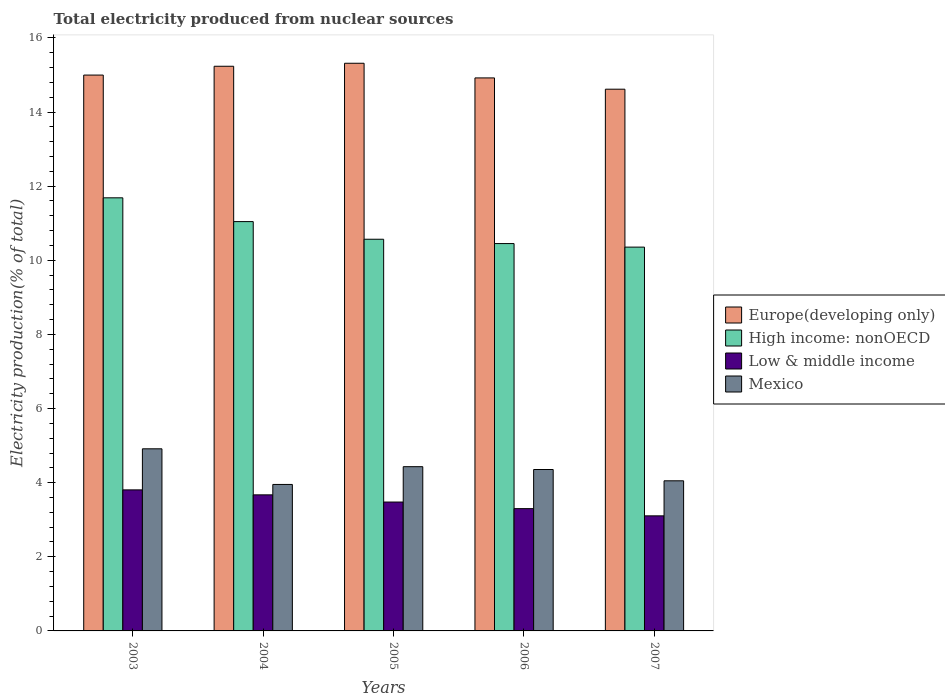How many groups of bars are there?
Offer a very short reply. 5. Are the number of bars on each tick of the X-axis equal?
Your answer should be compact. Yes. How many bars are there on the 4th tick from the left?
Offer a very short reply. 4. How many bars are there on the 4th tick from the right?
Make the answer very short. 4. In how many cases, is the number of bars for a given year not equal to the number of legend labels?
Keep it short and to the point. 0. What is the total electricity produced in Mexico in 2004?
Ensure brevity in your answer.  3.95. Across all years, what is the maximum total electricity produced in Mexico?
Your answer should be compact. 4.91. Across all years, what is the minimum total electricity produced in High income: nonOECD?
Provide a short and direct response. 10.36. What is the total total electricity produced in Europe(developing only) in the graph?
Provide a succinct answer. 75.09. What is the difference between the total electricity produced in Europe(developing only) in 2003 and that in 2004?
Keep it short and to the point. -0.24. What is the difference between the total electricity produced in Low & middle income in 2007 and the total electricity produced in High income: nonOECD in 2005?
Your response must be concise. -7.46. What is the average total electricity produced in High income: nonOECD per year?
Give a very brief answer. 10.82. In the year 2005, what is the difference between the total electricity produced in Low & middle income and total electricity produced in Mexico?
Your answer should be very brief. -0.95. What is the ratio of the total electricity produced in Europe(developing only) in 2004 to that in 2007?
Your answer should be very brief. 1.04. Is the total electricity produced in Europe(developing only) in 2003 less than that in 2005?
Give a very brief answer. Yes. What is the difference between the highest and the second highest total electricity produced in High income: nonOECD?
Provide a succinct answer. 0.64. What is the difference between the highest and the lowest total electricity produced in High income: nonOECD?
Your answer should be very brief. 1.33. What does the 3rd bar from the right in 2006 represents?
Ensure brevity in your answer.  High income: nonOECD. Is it the case that in every year, the sum of the total electricity produced in High income: nonOECD and total electricity produced in Mexico is greater than the total electricity produced in Europe(developing only)?
Keep it short and to the point. No. How many bars are there?
Provide a short and direct response. 20. Are all the bars in the graph horizontal?
Provide a short and direct response. No. Are the values on the major ticks of Y-axis written in scientific E-notation?
Provide a short and direct response. No. Does the graph contain any zero values?
Offer a very short reply. No. Does the graph contain grids?
Offer a very short reply. No. How many legend labels are there?
Your answer should be very brief. 4. What is the title of the graph?
Make the answer very short. Total electricity produced from nuclear sources. Does "Korea (Republic)" appear as one of the legend labels in the graph?
Make the answer very short. No. What is the label or title of the X-axis?
Provide a succinct answer. Years. What is the label or title of the Y-axis?
Make the answer very short. Electricity production(% of total). What is the Electricity production(% of total) of Europe(developing only) in 2003?
Give a very brief answer. 15. What is the Electricity production(% of total) of High income: nonOECD in 2003?
Provide a succinct answer. 11.69. What is the Electricity production(% of total) of Low & middle income in 2003?
Your response must be concise. 3.81. What is the Electricity production(% of total) of Mexico in 2003?
Make the answer very short. 4.91. What is the Electricity production(% of total) in Europe(developing only) in 2004?
Your response must be concise. 15.24. What is the Electricity production(% of total) of High income: nonOECD in 2004?
Your response must be concise. 11.04. What is the Electricity production(% of total) in Low & middle income in 2004?
Make the answer very short. 3.67. What is the Electricity production(% of total) of Mexico in 2004?
Your answer should be very brief. 3.95. What is the Electricity production(% of total) in Europe(developing only) in 2005?
Provide a short and direct response. 15.32. What is the Electricity production(% of total) in High income: nonOECD in 2005?
Provide a short and direct response. 10.57. What is the Electricity production(% of total) of Low & middle income in 2005?
Your response must be concise. 3.48. What is the Electricity production(% of total) in Mexico in 2005?
Provide a short and direct response. 4.43. What is the Electricity production(% of total) in Europe(developing only) in 2006?
Provide a succinct answer. 14.92. What is the Electricity production(% of total) of High income: nonOECD in 2006?
Your answer should be very brief. 10.45. What is the Electricity production(% of total) of Low & middle income in 2006?
Keep it short and to the point. 3.3. What is the Electricity production(% of total) in Mexico in 2006?
Your response must be concise. 4.36. What is the Electricity production(% of total) of Europe(developing only) in 2007?
Your answer should be very brief. 14.62. What is the Electricity production(% of total) in High income: nonOECD in 2007?
Provide a short and direct response. 10.36. What is the Electricity production(% of total) of Low & middle income in 2007?
Ensure brevity in your answer.  3.1. What is the Electricity production(% of total) in Mexico in 2007?
Offer a terse response. 4.05. Across all years, what is the maximum Electricity production(% of total) in Europe(developing only)?
Your answer should be very brief. 15.32. Across all years, what is the maximum Electricity production(% of total) of High income: nonOECD?
Give a very brief answer. 11.69. Across all years, what is the maximum Electricity production(% of total) in Low & middle income?
Your answer should be very brief. 3.81. Across all years, what is the maximum Electricity production(% of total) in Mexico?
Your answer should be compact. 4.91. Across all years, what is the minimum Electricity production(% of total) of Europe(developing only)?
Provide a succinct answer. 14.62. Across all years, what is the minimum Electricity production(% of total) of High income: nonOECD?
Provide a short and direct response. 10.36. Across all years, what is the minimum Electricity production(% of total) in Low & middle income?
Give a very brief answer. 3.1. Across all years, what is the minimum Electricity production(% of total) of Mexico?
Provide a succinct answer. 3.95. What is the total Electricity production(% of total) of Europe(developing only) in the graph?
Make the answer very short. 75.09. What is the total Electricity production(% of total) of High income: nonOECD in the graph?
Offer a very short reply. 54.1. What is the total Electricity production(% of total) in Low & middle income in the graph?
Offer a terse response. 17.36. What is the total Electricity production(% of total) of Mexico in the graph?
Give a very brief answer. 21.7. What is the difference between the Electricity production(% of total) of Europe(developing only) in 2003 and that in 2004?
Your answer should be compact. -0.24. What is the difference between the Electricity production(% of total) of High income: nonOECD in 2003 and that in 2004?
Provide a succinct answer. 0.64. What is the difference between the Electricity production(% of total) of Low & middle income in 2003 and that in 2004?
Keep it short and to the point. 0.13. What is the difference between the Electricity production(% of total) of Mexico in 2003 and that in 2004?
Provide a short and direct response. 0.96. What is the difference between the Electricity production(% of total) in Europe(developing only) in 2003 and that in 2005?
Your answer should be compact. -0.32. What is the difference between the Electricity production(% of total) in High income: nonOECD in 2003 and that in 2005?
Ensure brevity in your answer.  1.12. What is the difference between the Electricity production(% of total) of Low & middle income in 2003 and that in 2005?
Provide a succinct answer. 0.33. What is the difference between the Electricity production(% of total) of Mexico in 2003 and that in 2005?
Give a very brief answer. 0.48. What is the difference between the Electricity production(% of total) of Europe(developing only) in 2003 and that in 2006?
Give a very brief answer. 0.08. What is the difference between the Electricity production(% of total) in High income: nonOECD in 2003 and that in 2006?
Provide a succinct answer. 1.23. What is the difference between the Electricity production(% of total) of Low & middle income in 2003 and that in 2006?
Your answer should be compact. 0.51. What is the difference between the Electricity production(% of total) in Mexico in 2003 and that in 2006?
Your answer should be very brief. 0.56. What is the difference between the Electricity production(% of total) in Europe(developing only) in 2003 and that in 2007?
Offer a very short reply. 0.38. What is the difference between the Electricity production(% of total) of High income: nonOECD in 2003 and that in 2007?
Give a very brief answer. 1.33. What is the difference between the Electricity production(% of total) of Low & middle income in 2003 and that in 2007?
Provide a succinct answer. 0.7. What is the difference between the Electricity production(% of total) of Mexico in 2003 and that in 2007?
Make the answer very short. 0.86. What is the difference between the Electricity production(% of total) of Europe(developing only) in 2004 and that in 2005?
Your answer should be very brief. -0.08. What is the difference between the Electricity production(% of total) of High income: nonOECD in 2004 and that in 2005?
Ensure brevity in your answer.  0.48. What is the difference between the Electricity production(% of total) in Low & middle income in 2004 and that in 2005?
Keep it short and to the point. 0.19. What is the difference between the Electricity production(% of total) of Mexico in 2004 and that in 2005?
Your response must be concise. -0.48. What is the difference between the Electricity production(% of total) of Europe(developing only) in 2004 and that in 2006?
Provide a succinct answer. 0.31. What is the difference between the Electricity production(% of total) of High income: nonOECD in 2004 and that in 2006?
Keep it short and to the point. 0.59. What is the difference between the Electricity production(% of total) of Low & middle income in 2004 and that in 2006?
Give a very brief answer. 0.37. What is the difference between the Electricity production(% of total) of Mexico in 2004 and that in 2006?
Make the answer very short. -0.4. What is the difference between the Electricity production(% of total) in Europe(developing only) in 2004 and that in 2007?
Provide a succinct answer. 0.62. What is the difference between the Electricity production(% of total) in High income: nonOECD in 2004 and that in 2007?
Make the answer very short. 0.69. What is the difference between the Electricity production(% of total) in Low & middle income in 2004 and that in 2007?
Provide a succinct answer. 0.57. What is the difference between the Electricity production(% of total) in Mexico in 2004 and that in 2007?
Provide a short and direct response. -0.1. What is the difference between the Electricity production(% of total) in Europe(developing only) in 2005 and that in 2006?
Provide a succinct answer. 0.4. What is the difference between the Electricity production(% of total) of High income: nonOECD in 2005 and that in 2006?
Keep it short and to the point. 0.12. What is the difference between the Electricity production(% of total) in Low & middle income in 2005 and that in 2006?
Offer a very short reply. 0.18. What is the difference between the Electricity production(% of total) of Mexico in 2005 and that in 2006?
Your answer should be compact. 0.08. What is the difference between the Electricity production(% of total) in Europe(developing only) in 2005 and that in 2007?
Provide a succinct answer. 0.7. What is the difference between the Electricity production(% of total) of High income: nonOECD in 2005 and that in 2007?
Provide a short and direct response. 0.21. What is the difference between the Electricity production(% of total) of Low & middle income in 2005 and that in 2007?
Provide a succinct answer. 0.37. What is the difference between the Electricity production(% of total) in Mexico in 2005 and that in 2007?
Offer a very short reply. 0.38. What is the difference between the Electricity production(% of total) of Europe(developing only) in 2006 and that in 2007?
Offer a terse response. 0.3. What is the difference between the Electricity production(% of total) in High income: nonOECD in 2006 and that in 2007?
Make the answer very short. 0.1. What is the difference between the Electricity production(% of total) in Low & middle income in 2006 and that in 2007?
Keep it short and to the point. 0.19. What is the difference between the Electricity production(% of total) in Mexico in 2006 and that in 2007?
Provide a short and direct response. 0.3. What is the difference between the Electricity production(% of total) of Europe(developing only) in 2003 and the Electricity production(% of total) of High income: nonOECD in 2004?
Provide a short and direct response. 3.95. What is the difference between the Electricity production(% of total) of Europe(developing only) in 2003 and the Electricity production(% of total) of Low & middle income in 2004?
Keep it short and to the point. 11.33. What is the difference between the Electricity production(% of total) in Europe(developing only) in 2003 and the Electricity production(% of total) in Mexico in 2004?
Provide a succinct answer. 11.05. What is the difference between the Electricity production(% of total) of High income: nonOECD in 2003 and the Electricity production(% of total) of Low & middle income in 2004?
Your answer should be very brief. 8.01. What is the difference between the Electricity production(% of total) of High income: nonOECD in 2003 and the Electricity production(% of total) of Mexico in 2004?
Provide a succinct answer. 7.73. What is the difference between the Electricity production(% of total) in Low & middle income in 2003 and the Electricity production(% of total) in Mexico in 2004?
Make the answer very short. -0.15. What is the difference between the Electricity production(% of total) of Europe(developing only) in 2003 and the Electricity production(% of total) of High income: nonOECD in 2005?
Your response must be concise. 4.43. What is the difference between the Electricity production(% of total) of Europe(developing only) in 2003 and the Electricity production(% of total) of Low & middle income in 2005?
Offer a terse response. 11.52. What is the difference between the Electricity production(% of total) of Europe(developing only) in 2003 and the Electricity production(% of total) of Mexico in 2005?
Offer a very short reply. 10.57. What is the difference between the Electricity production(% of total) in High income: nonOECD in 2003 and the Electricity production(% of total) in Low & middle income in 2005?
Keep it short and to the point. 8.21. What is the difference between the Electricity production(% of total) of High income: nonOECD in 2003 and the Electricity production(% of total) of Mexico in 2005?
Ensure brevity in your answer.  7.25. What is the difference between the Electricity production(% of total) of Low & middle income in 2003 and the Electricity production(% of total) of Mexico in 2005?
Provide a succinct answer. -0.63. What is the difference between the Electricity production(% of total) of Europe(developing only) in 2003 and the Electricity production(% of total) of High income: nonOECD in 2006?
Your response must be concise. 4.55. What is the difference between the Electricity production(% of total) in Europe(developing only) in 2003 and the Electricity production(% of total) in Low & middle income in 2006?
Ensure brevity in your answer.  11.7. What is the difference between the Electricity production(% of total) of Europe(developing only) in 2003 and the Electricity production(% of total) of Mexico in 2006?
Your response must be concise. 10.64. What is the difference between the Electricity production(% of total) in High income: nonOECD in 2003 and the Electricity production(% of total) in Low & middle income in 2006?
Make the answer very short. 8.39. What is the difference between the Electricity production(% of total) of High income: nonOECD in 2003 and the Electricity production(% of total) of Mexico in 2006?
Your answer should be compact. 7.33. What is the difference between the Electricity production(% of total) of Low & middle income in 2003 and the Electricity production(% of total) of Mexico in 2006?
Ensure brevity in your answer.  -0.55. What is the difference between the Electricity production(% of total) in Europe(developing only) in 2003 and the Electricity production(% of total) in High income: nonOECD in 2007?
Make the answer very short. 4.64. What is the difference between the Electricity production(% of total) of Europe(developing only) in 2003 and the Electricity production(% of total) of Low & middle income in 2007?
Offer a terse response. 11.89. What is the difference between the Electricity production(% of total) of Europe(developing only) in 2003 and the Electricity production(% of total) of Mexico in 2007?
Keep it short and to the point. 10.95. What is the difference between the Electricity production(% of total) in High income: nonOECD in 2003 and the Electricity production(% of total) in Low & middle income in 2007?
Keep it short and to the point. 8.58. What is the difference between the Electricity production(% of total) in High income: nonOECD in 2003 and the Electricity production(% of total) in Mexico in 2007?
Give a very brief answer. 7.64. What is the difference between the Electricity production(% of total) in Low & middle income in 2003 and the Electricity production(% of total) in Mexico in 2007?
Your answer should be compact. -0.24. What is the difference between the Electricity production(% of total) in Europe(developing only) in 2004 and the Electricity production(% of total) in High income: nonOECD in 2005?
Keep it short and to the point. 4.67. What is the difference between the Electricity production(% of total) in Europe(developing only) in 2004 and the Electricity production(% of total) in Low & middle income in 2005?
Make the answer very short. 11.76. What is the difference between the Electricity production(% of total) in Europe(developing only) in 2004 and the Electricity production(% of total) in Mexico in 2005?
Ensure brevity in your answer.  10.8. What is the difference between the Electricity production(% of total) of High income: nonOECD in 2004 and the Electricity production(% of total) of Low & middle income in 2005?
Offer a very short reply. 7.57. What is the difference between the Electricity production(% of total) of High income: nonOECD in 2004 and the Electricity production(% of total) of Mexico in 2005?
Make the answer very short. 6.61. What is the difference between the Electricity production(% of total) of Low & middle income in 2004 and the Electricity production(% of total) of Mexico in 2005?
Offer a terse response. -0.76. What is the difference between the Electricity production(% of total) in Europe(developing only) in 2004 and the Electricity production(% of total) in High income: nonOECD in 2006?
Your response must be concise. 4.78. What is the difference between the Electricity production(% of total) in Europe(developing only) in 2004 and the Electricity production(% of total) in Low & middle income in 2006?
Ensure brevity in your answer.  11.94. What is the difference between the Electricity production(% of total) in Europe(developing only) in 2004 and the Electricity production(% of total) in Mexico in 2006?
Give a very brief answer. 10.88. What is the difference between the Electricity production(% of total) of High income: nonOECD in 2004 and the Electricity production(% of total) of Low & middle income in 2006?
Provide a succinct answer. 7.74. What is the difference between the Electricity production(% of total) of High income: nonOECD in 2004 and the Electricity production(% of total) of Mexico in 2006?
Your response must be concise. 6.69. What is the difference between the Electricity production(% of total) of Low & middle income in 2004 and the Electricity production(% of total) of Mexico in 2006?
Offer a terse response. -0.68. What is the difference between the Electricity production(% of total) in Europe(developing only) in 2004 and the Electricity production(% of total) in High income: nonOECD in 2007?
Offer a terse response. 4.88. What is the difference between the Electricity production(% of total) of Europe(developing only) in 2004 and the Electricity production(% of total) of Low & middle income in 2007?
Offer a very short reply. 12.13. What is the difference between the Electricity production(% of total) of Europe(developing only) in 2004 and the Electricity production(% of total) of Mexico in 2007?
Your answer should be compact. 11.18. What is the difference between the Electricity production(% of total) of High income: nonOECD in 2004 and the Electricity production(% of total) of Low & middle income in 2007?
Keep it short and to the point. 7.94. What is the difference between the Electricity production(% of total) in High income: nonOECD in 2004 and the Electricity production(% of total) in Mexico in 2007?
Keep it short and to the point. 6.99. What is the difference between the Electricity production(% of total) in Low & middle income in 2004 and the Electricity production(% of total) in Mexico in 2007?
Your answer should be compact. -0.38. What is the difference between the Electricity production(% of total) of Europe(developing only) in 2005 and the Electricity production(% of total) of High income: nonOECD in 2006?
Provide a short and direct response. 4.87. What is the difference between the Electricity production(% of total) of Europe(developing only) in 2005 and the Electricity production(% of total) of Low & middle income in 2006?
Your response must be concise. 12.02. What is the difference between the Electricity production(% of total) of Europe(developing only) in 2005 and the Electricity production(% of total) of Mexico in 2006?
Offer a terse response. 10.96. What is the difference between the Electricity production(% of total) in High income: nonOECD in 2005 and the Electricity production(% of total) in Low & middle income in 2006?
Offer a terse response. 7.27. What is the difference between the Electricity production(% of total) in High income: nonOECD in 2005 and the Electricity production(% of total) in Mexico in 2006?
Ensure brevity in your answer.  6.21. What is the difference between the Electricity production(% of total) in Low & middle income in 2005 and the Electricity production(% of total) in Mexico in 2006?
Your answer should be compact. -0.88. What is the difference between the Electricity production(% of total) of Europe(developing only) in 2005 and the Electricity production(% of total) of High income: nonOECD in 2007?
Offer a terse response. 4.96. What is the difference between the Electricity production(% of total) in Europe(developing only) in 2005 and the Electricity production(% of total) in Low & middle income in 2007?
Offer a terse response. 12.21. What is the difference between the Electricity production(% of total) of Europe(developing only) in 2005 and the Electricity production(% of total) of Mexico in 2007?
Offer a very short reply. 11.27. What is the difference between the Electricity production(% of total) in High income: nonOECD in 2005 and the Electricity production(% of total) in Low & middle income in 2007?
Offer a terse response. 7.46. What is the difference between the Electricity production(% of total) in High income: nonOECD in 2005 and the Electricity production(% of total) in Mexico in 2007?
Offer a terse response. 6.52. What is the difference between the Electricity production(% of total) of Low & middle income in 2005 and the Electricity production(% of total) of Mexico in 2007?
Offer a terse response. -0.57. What is the difference between the Electricity production(% of total) in Europe(developing only) in 2006 and the Electricity production(% of total) in High income: nonOECD in 2007?
Your answer should be very brief. 4.57. What is the difference between the Electricity production(% of total) in Europe(developing only) in 2006 and the Electricity production(% of total) in Low & middle income in 2007?
Ensure brevity in your answer.  11.82. What is the difference between the Electricity production(% of total) of Europe(developing only) in 2006 and the Electricity production(% of total) of Mexico in 2007?
Provide a short and direct response. 10.87. What is the difference between the Electricity production(% of total) of High income: nonOECD in 2006 and the Electricity production(% of total) of Low & middle income in 2007?
Your answer should be compact. 7.35. What is the difference between the Electricity production(% of total) of High income: nonOECD in 2006 and the Electricity production(% of total) of Mexico in 2007?
Your answer should be compact. 6.4. What is the difference between the Electricity production(% of total) in Low & middle income in 2006 and the Electricity production(% of total) in Mexico in 2007?
Offer a very short reply. -0.75. What is the average Electricity production(% of total) in Europe(developing only) per year?
Your answer should be very brief. 15.02. What is the average Electricity production(% of total) in High income: nonOECD per year?
Provide a succinct answer. 10.82. What is the average Electricity production(% of total) in Low & middle income per year?
Keep it short and to the point. 3.47. What is the average Electricity production(% of total) in Mexico per year?
Provide a succinct answer. 4.34. In the year 2003, what is the difference between the Electricity production(% of total) in Europe(developing only) and Electricity production(% of total) in High income: nonOECD?
Ensure brevity in your answer.  3.31. In the year 2003, what is the difference between the Electricity production(% of total) in Europe(developing only) and Electricity production(% of total) in Low & middle income?
Ensure brevity in your answer.  11.19. In the year 2003, what is the difference between the Electricity production(% of total) of Europe(developing only) and Electricity production(% of total) of Mexico?
Your response must be concise. 10.08. In the year 2003, what is the difference between the Electricity production(% of total) in High income: nonOECD and Electricity production(% of total) in Low & middle income?
Make the answer very short. 7.88. In the year 2003, what is the difference between the Electricity production(% of total) of High income: nonOECD and Electricity production(% of total) of Mexico?
Your response must be concise. 6.77. In the year 2003, what is the difference between the Electricity production(% of total) in Low & middle income and Electricity production(% of total) in Mexico?
Make the answer very short. -1.11. In the year 2004, what is the difference between the Electricity production(% of total) in Europe(developing only) and Electricity production(% of total) in High income: nonOECD?
Make the answer very short. 4.19. In the year 2004, what is the difference between the Electricity production(% of total) of Europe(developing only) and Electricity production(% of total) of Low & middle income?
Keep it short and to the point. 11.56. In the year 2004, what is the difference between the Electricity production(% of total) of Europe(developing only) and Electricity production(% of total) of Mexico?
Your answer should be compact. 11.28. In the year 2004, what is the difference between the Electricity production(% of total) in High income: nonOECD and Electricity production(% of total) in Low & middle income?
Make the answer very short. 7.37. In the year 2004, what is the difference between the Electricity production(% of total) in High income: nonOECD and Electricity production(% of total) in Mexico?
Keep it short and to the point. 7.09. In the year 2004, what is the difference between the Electricity production(% of total) in Low & middle income and Electricity production(% of total) in Mexico?
Your answer should be very brief. -0.28. In the year 2005, what is the difference between the Electricity production(% of total) of Europe(developing only) and Electricity production(% of total) of High income: nonOECD?
Offer a terse response. 4.75. In the year 2005, what is the difference between the Electricity production(% of total) in Europe(developing only) and Electricity production(% of total) in Low & middle income?
Offer a terse response. 11.84. In the year 2005, what is the difference between the Electricity production(% of total) in Europe(developing only) and Electricity production(% of total) in Mexico?
Your response must be concise. 10.88. In the year 2005, what is the difference between the Electricity production(% of total) of High income: nonOECD and Electricity production(% of total) of Low & middle income?
Your answer should be compact. 7.09. In the year 2005, what is the difference between the Electricity production(% of total) in High income: nonOECD and Electricity production(% of total) in Mexico?
Ensure brevity in your answer.  6.14. In the year 2005, what is the difference between the Electricity production(% of total) of Low & middle income and Electricity production(% of total) of Mexico?
Offer a terse response. -0.95. In the year 2006, what is the difference between the Electricity production(% of total) of Europe(developing only) and Electricity production(% of total) of High income: nonOECD?
Offer a terse response. 4.47. In the year 2006, what is the difference between the Electricity production(% of total) of Europe(developing only) and Electricity production(% of total) of Low & middle income?
Offer a terse response. 11.62. In the year 2006, what is the difference between the Electricity production(% of total) of Europe(developing only) and Electricity production(% of total) of Mexico?
Provide a succinct answer. 10.57. In the year 2006, what is the difference between the Electricity production(% of total) of High income: nonOECD and Electricity production(% of total) of Low & middle income?
Offer a terse response. 7.15. In the year 2006, what is the difference between the Electricity production(% of total) of High income: nonOECD and Electricity production(% of total) of Mexico?
Offer a very short reply. 6.1. In the year 2006, what is the difference between the Electricity production(% of total) in Low & middle income and Electricity production(% of total) in Mexico?
Provide a short and direct response. -1.06. In the year 2007, what is the difference between the Electricity production(% of total) of Europe(developing only) and Electricity production(% of total) of High income: nonOECD?
Your answer should be very brief. 4.26. In the year 2007, what is the difference between the Electricity production(% of total) in Europe(developing only) and Electricity production(% of total) in Low & middle income?
Make the answer very short. 11.51. In the year 2007, what is the difference between the Electricity production(% of total) in Europe(developing only) and Electricity production(% of total) in Mexico?
Ensure brevity in your answer.  10.57. In the year 2007, what is the difference between the Electricity production(% of total) in High income: nonOECD and Electricity production(% of total) in Low & middle income?
Ensure brevity in your answer.  7.25. In the year 2007, what is the difference between the Electricity production(% of total) in High income: nonOECD and Electricity production(% of total) in Mexico?
Provide a succinct answer. 6.31. In the year 2007, what is the difference between the Electricity production(% of total) of Low & middle income and Electricity production(% of total) of Mexico?
Provide a short and direct response. -0.95. What is the ratio of the Electricity production(% of total) in Europe(developing only) in 2003 to that in 2004?
Your answer should be compact. 0.98. What is the ratio of the Electricity production(% of total) of High income: nonOECD in 2003 to that in 2004?
Your answer should be compact. 1.06. What is the ratio of the Electricity production(% of total) in Low & middle income in 2003 to that in 2004?
Your answer should be very brief. 1.04. What is the ratio of the Electricity production(% of total) of Mexico in 2003 to that in 2004?
Your response must be concise. 1.24. What is the ratio of the Electricity production(% of total) in Europe(developing only) in 2003 to that in 2005?
Make the answer very short. 0.98. What is the ratio of the Electricity production(% of total) of High income: nonOECD in 2003 to that in 2005?
Provide a succinct answer. 1.11. What is the ratio of the Electricity production(% of total) of Low & middle income in 2003 to that in 2005?
Offer a terse response. 1.09. What is the ratio of the Electricity production(% of total) in Mexico in 2003 to that in 2005?
Offer a very short reply. 1.11. What is the ratio of the Electricity production(% of total) of Europe(developing only) in 2003 to that in 2006?
Give a very brief answer. 1.01. What is the ratio of the Electricity production(% of total) in High income: nonOECD in 2003 to that in 2006?
Offer a terse response. 1.12. What is the ratio of the Electricity production(% of total) of Low & middle income in 2003 to that in 2006?
Your answer should be compact. 1.15. What is the ratio of the Electricity production(% of total) of Mexico in 2003 to that in 2006?
Make the answer very short. 1.13. What is the ratio of the Electricity production(% of total) in Europe(developing only) in 2003 to that in 2007?
Keep it short and to the point. 1.03. What is the ratio of the Electricity production(% of total) of High income: nonOECD in 2003 to that in 2007?
Provide a short and direct response. 1.13. What is the ratio of the Electricity production(% of total) in Low & middle income in 2003 to that in 2007?
Your answer should be compact. 1.23. What is the ratio of the Electricity production(% of total) of Mexico in 2003 to that in 2007?
Provide a short and direct response. 1.21. What is the ratio of the Electricity production(% of total) of High income: nonOECD in 2004 to that in 2005?
Make the answer very short. 1.04. What is the ratio of the Electricity production(% of total) of Low & middle income in 2004 to that in 2005?
Provide a succinct answer. 1.06. What is the ratio of the Electricity production(% of total) in Mexico in 2004 to that in 2005?
Keep it short and to the point. 0.89. What is the ratio of the Electricity production(% of total) in Europe(developing only) in 2004 to that in 2006?
Offer a very short reply. 1.02. What is the ratio of the Electricity production(% of total) in High income: nonOECD in 2004 to that in 2006?
Your response must be concise. 1.06. What is the ratio of the Electricity production(% of total) in Low & middle income in 2004 to that in 2006?
Provide a short and direct response. 1.11. What is the ratio of the Electricity production(% of total) in Mexico in 2004 to that in 2006?
Your response must be concise. 0.91. What is the ratio of the Electricity production(% of total) of Europe(developing only) in 2004 to that in 2007?
Give a very brief answer. 1.04. What is the ratio of the Electricity production(% of total) of High income: nonOECD in 2004 to that in 2007?
Offer a very short reply. 1.07. What is the ratio of the Electricity production(% of total) in Low & middle income in 2004 to that in 2007?
Offer a very short reply. 1.18. What is the ratio of the Electricity production(% of total) in Mexico in 2004 to that in 2007?
Your answer should be compact. 0.98. What is the ratio of the Electricity production(% of total) of Europe(developing only) in 2005 to that in 2006?
Give a very brief answer. 1.03. What is the ratio of the Electricity production(% of total) of High income: nonOECD in 2005 to that in 2006?
Give a very brief answer. 1.01. What is the ratio of the Electricity production(% of total) in Low & middle income in 2005 to that in 2006?
Your response must be concise. 1.05. What is the ratio of the Electricity production(% of total) in Mexico in 2005 to that in 2006?
Keep it short and to the point. 1.02. What is the ratio of the Electricity production(% of total) of Europe(developing only) in 2005 to that in 2007?
Your response must be concise. 1.05. What is the ratio of the Electricity production(% of total) in High income: nonOECD in 2005 to that in 2007?
Your answer should be very brief. 1.02. What is the ratio of the Electricity production(% of total) of Low & middle income in 2005 to that in 2007?
Ensure brevity in your answer.  1.12. What is the ratio of the Electricity production(% of total) in Mexico in 2005 to that in 2007?
Offer a very short reply. 1.09. What is the ratio of the Electricity production(% of total) in Europe(developing only) in 2006 to that in 2007?
Keep it short and to the point. 1.02. What is the ratio of the Electricity production(% of total) in High income: nonOECD in 2006 to that in 2007?
Give a very brief answer. 1.01. What is the ratio of the Electricity production(% of total) of Low & middle income in 2006 to that in 2007?
Ensure brevity in your answer.  1.06. What is the ratio of the Electricity production(% of total) of Mexico in 2006 to that in 2007?
Your answer should be very brief. 1.08. What is the difference between the highest and the second highest Electricity production(% of total) of Europe(developing only)?
Your answer should be compact. 0.08. What is the difference between the highest and the second highest Electricity production(% of total) of High income: nonOECD?
Offer a very short reply. 0.64. What is the difference between the highest and the second highest Electricity production(% of total) in Low & middle income?
Offer a very short reply. 0.13. What is the difference between the highest and the second highest Electricity production(% of total) in Mexico?
Offer a very short reply. 0.48. What is the difference between the highest and the lowest Electricity production(% of total) in Europe(developing only)?
Your answer should be compact. 0.7. What is the difference between the highest and the lowest Electricity production(% of total) of High income: nonOECD?
Provide a short and direct response. 1.33. What is the difference between the highest and the lowest Electricity production(% of total) of Low & middle income?
Offer a terse response. 0.7. What is the difference between the highest and the lowest Electricity production(% of total) in Mexico?
Provide a short and direct response. 0.96. 